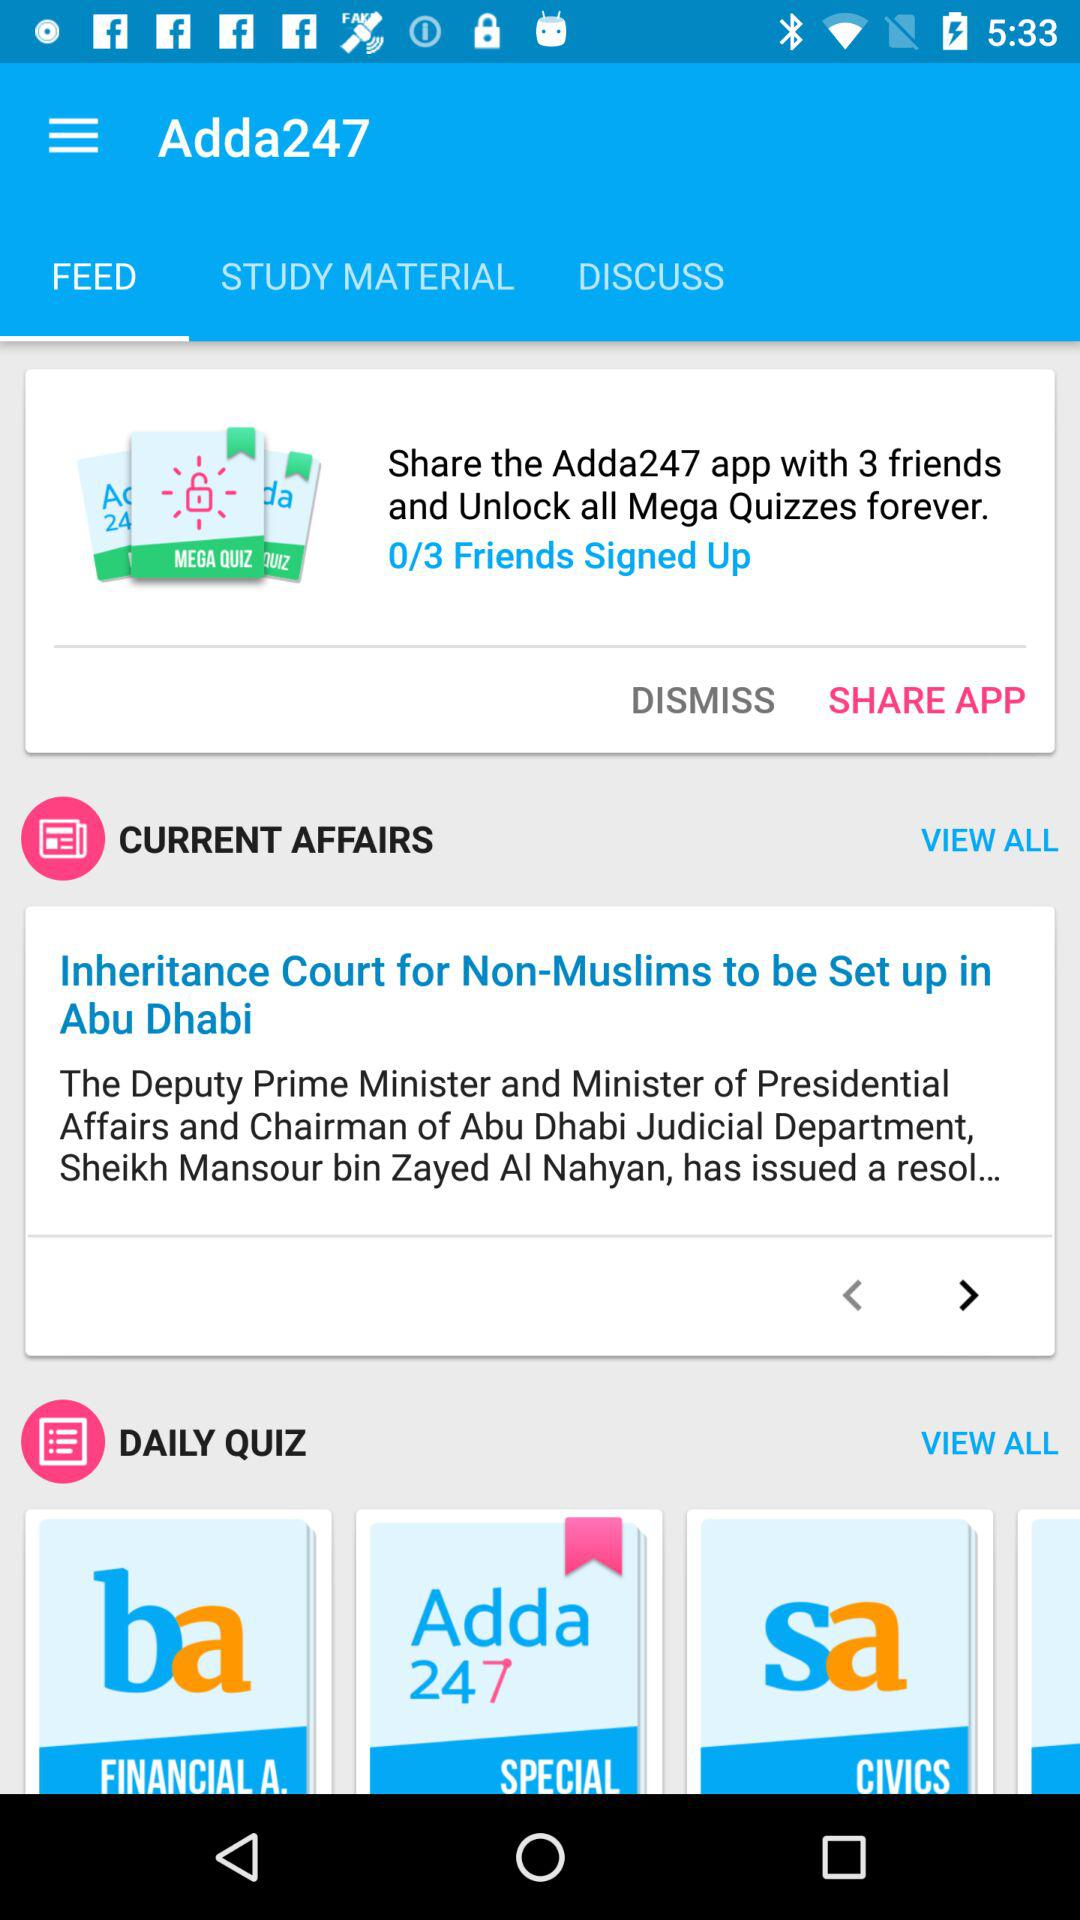How many friends are signed up? The friends that have signed up are 0. 